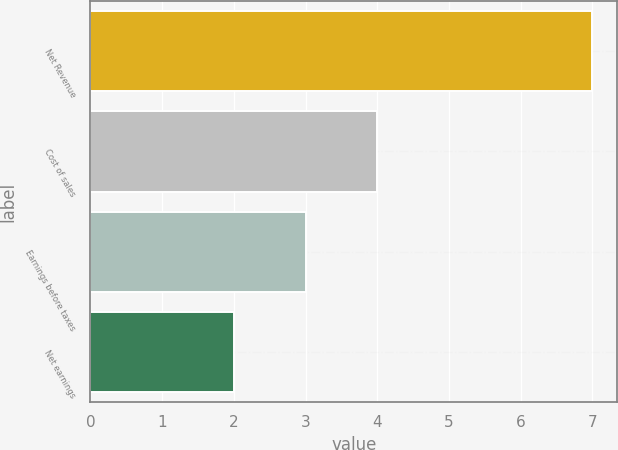<chart> <loc_0><loc_0><loc_500><loc_500><bar_chart><fcel>Net Revenue<fcel>Cost of sales<fcel>Earnings before taxes<fcel>Net earnings<nl><fcel>7<fcel>4<fcel>3<fcel>2<nl></chart> 